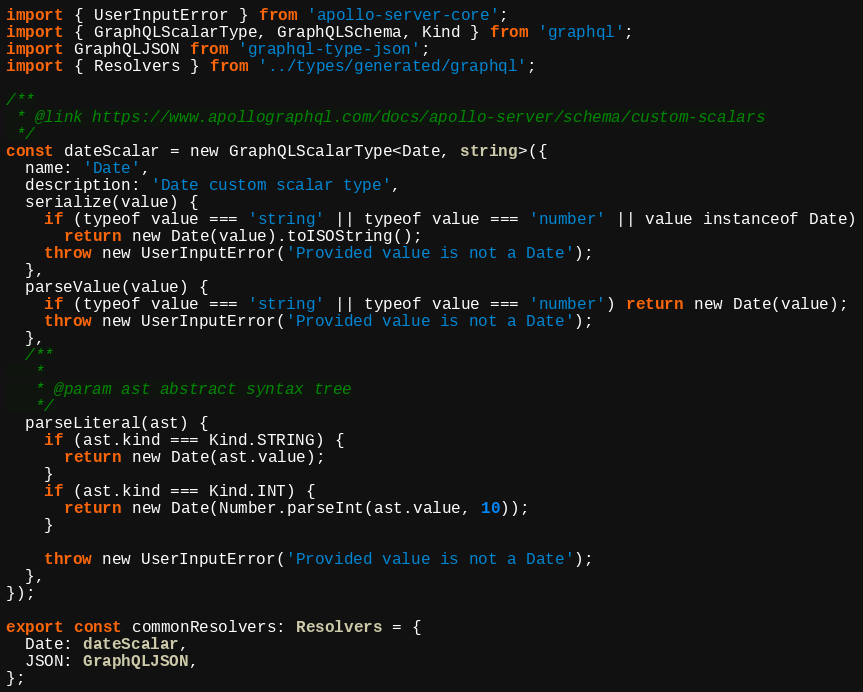Convert code to text. <code><loc_0><loc_0><loc_500><loc_500><_TypeScript_>import { UserInputError } from 'apollo-server-core';
import { GraphQLScalarType, GraphQLSchema, Kind } from 'graphql';
import GraphQLJSON from 'graphql-type-json';
import { Resolvers } from '../types/generated/graphql';

/**
 * @link https://www.apollographql.com/docs/apollo-server/schema/custom-scalars
 */
const dateScalar = new GraphQLScalarType<Date, string>({
  name: 'Date',
  description: 'Date custom scalar type',
  serialize(value) {
    if (typeof value === 'string' || typeof value === 'number' || value instanceof Date)
      return new Date(value).toISOString();
    throw new UserInputError('Provided value is not a Date');
  },
  parseValue(value) {
    if (typeof value === 'string' || typeof value === 'number') return new Date(value);
    throw new UserInputError('Provided value is not a Date');
  },
  /**
   *
   * @param ast abstract syntax tree
   */
  parseLiteral(ast) {
    if (ast.kind === Kind.STRING) {
      return new Date(ast.value);
    }
    if (ast.kind === Kind.INT) {
      return new Date(Number.parseInt(ast.value, 10));
    }

    throw new UserInputError('Provided value is not a Date');
  },
});

export const commonResolvers: Resolvers = {
  Date: dateScalar,
  JSON: GraphQLJSON,
};
</code> 